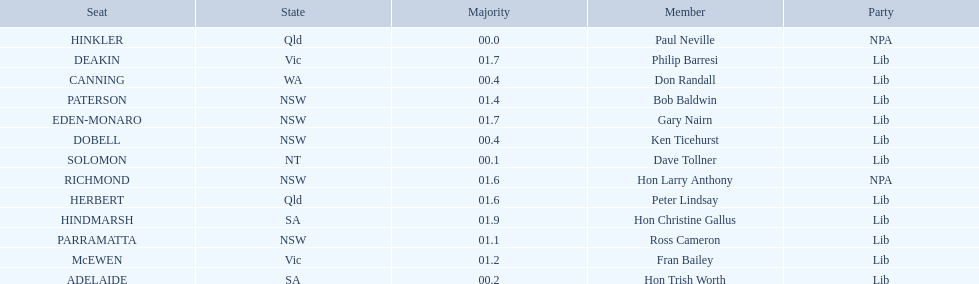Tell me the number of seats from nsw? 5. 